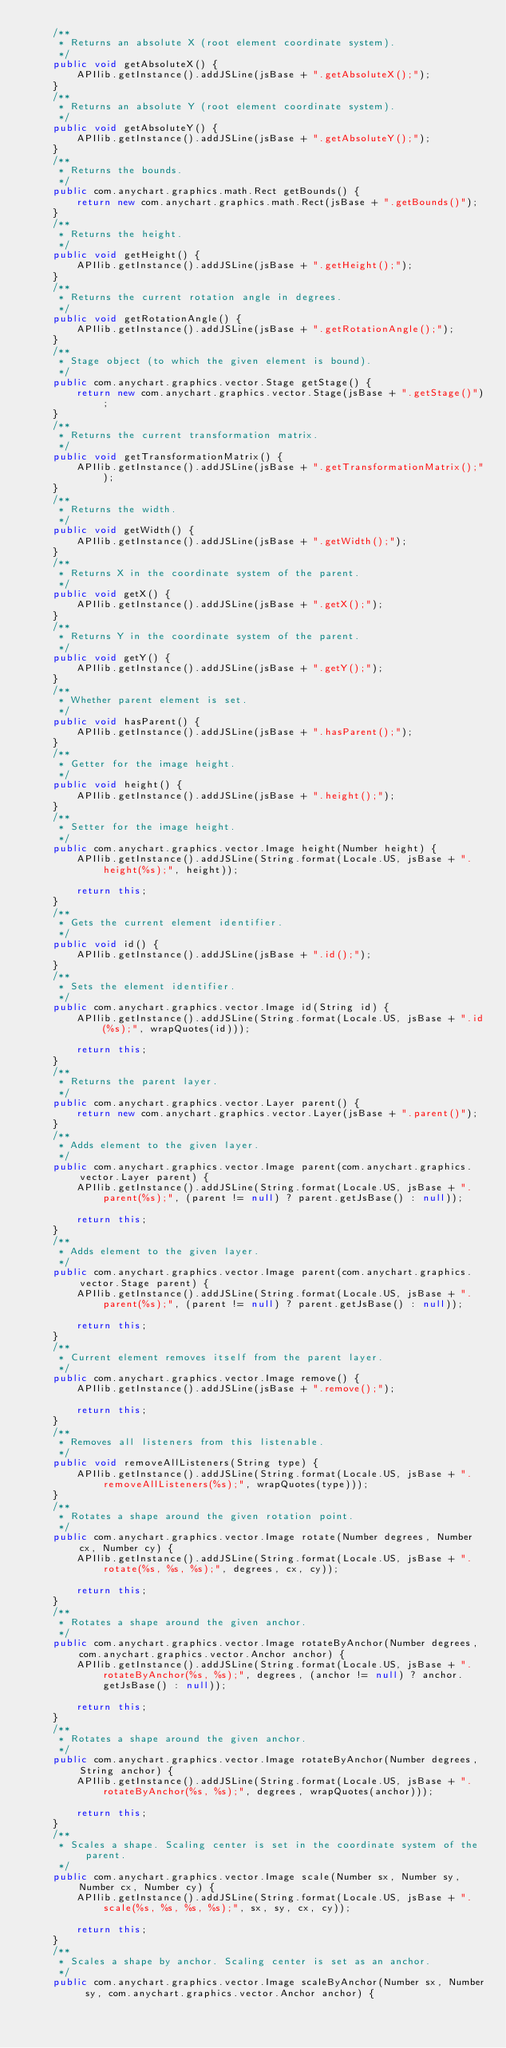<code> <loc_0><loc_0><loc_500><loc_500><_Java_>    /**
     * Returns an absolute X (root element coordinate system).
     */
    public void getAbsoluteX() {
        APIlib.getInstance().addJSLine(jsBase + ".getAbsoluteX();");
    }
    /**
     * Returns an absolute Y (root element coordinate system).
     */
    public void getAbsoluteY() {
        APIlib.getInstance().addJSLine(jsBase + ".getAbsoluteY();");
    }
    /**
     * Returns the bounds.
     */
    public com.anychart.graphics.math.Rect getBounds() {
        return new com.anychart.graphics.math.Rect(jsBase + ".getBounds()");
    }
    /**
     * Returns the height.
     */
    public void getHeight() {
        APIlib.getInstance().addJSLine(jsBase + ".getHeight();");
    }
    /**
     * Returns the current rotation angle in degrees.
     */
    public void getRotationAngle() {
        APIlib.getInstance().addJSLine(jsBase + ".getRotationAngle();");
    }
    /**
     * Stage object (to which the given element is bound).
     */
    public com.anychart.graphics.vector.Stage getStage() {
        return new com.anychart.graphics.vector.Stage(jsBase + ".getStage()");
    }
    /**
     * Returns the current transformation matrix.
     */
    public void getTransformationMatrix() {
        APIlib.getInstance().addJSLine(jsBase + ".getTransformationMatrix();");
    }
    /**
     * Returns the width.
     */
    public void getWidth() {
        APIlib.getInstance().addJSLine(jsBase + ".getWidth();");
    }
    /**
     * Returns X in the coordinate system of the parent.
     */
    public void getX() {
        APIlib.getInstance().addJSLine(jsBase + ".getX();");
    }
    /**
     * Returns Y in the coordinate system of the parent.
     */
    public void getY() {
        APIlib.getInstance().addJSLine(jsBase + ".getY();");
    }
    /**
     * Whether parent element is set.
     */
    public void hasParent() {
        APIlib.getInstance().addJSLine(jsBase + ".hasParent();");
    }
    /**
     * Getter for the image height.
     */
    public void height() {
        APIlib.getInstance().addJSLine(jsBase + ".height();");
    }
    /**
     * Setter for the image height.
     */
    public com.anychart.graphics.vector.Image height(Number height) {
        APIlib.getInstance().addJSLine(String.format(Locale.US, jsBase + ".height(%s);", height));

        return this;
    }
    /**
     * Gets the current element identifier.
     */
    public void id() {
        APIlib.getInstance().addJSLine(jsBase + ".id();");
    }
    /**
     * Sets the element identifier.
     */
    public com.anychart.graphics.vector.Image id(String id) {
        APIlib.getInstance().addJSLine(String.format(Locale.US, jsBase + ".id(%s);", wrapQuotes(id)));

        return this;
    }
    /**
     * Returns the parent layer.
     */
    public com.anychart.graphics.vector.Layer parent() {
        return new com.anychart.graphics.vector.Layer(jsBase + ".parent()");
    }
    /**
     * Adds element to the given layer.
     */
    public com.anychart.graphics.vector.Image parent(com.anychart.graphics.vector.Layer parent) {
        APIlib.getInstance().addJSLine(String.format(Locale.US, jsBase + ".parent(%s);", (parent != null) ? parent.getJsBase() : null));

        return this;
    }
    /**
     * Adds element to the given layer.
     */
    public com.anychart.graphics.vector.Image parent(com.anychart.graphics.vector.Stage parent) {
        APIlib.getInstance().addJSLine(String.format(Locale.US, jsBase + ".parent(%s);", (parent != null) ? parent.getJsBase() : null));

        return this;
    }
    /**
     * Current element removes itself from the parent layer.
     */
    public com.anychart.graphics.vector.Image remove() {
        APIlib.getInstance().addJSLine(jsBase + ".remove();");

        return this;
    }
    /**
     * Removes all listeners from this listenable.
     */
    public void removeAllListeners(String type) {
        APIlib.getInstance().addJSLine(String.format(Locale.US, jsBase + ".removeAllListeners(%s);", wrapQuotes(type)));
    }
    /**
     * Rotates a shape around the given rotation point.
     */
    public com.anychart.graphics.vector.Image rotate(Number degrees, Number cx, Number cy) {
        APIlib.getInstance().addJSLine(String.format(Locale.US, jsBase + ".rotate(%s, %s, %s);", degrees, cx, cy));

        return this;
    }
    /**
     * Rotates a shape around the given anchor.
     */
    public com.anychart.graphics.vector.Image rotateByAnchor(Number degrees, com.anychart.graphics.vector.Anchor anchor) {
        APIlib.getInstance().addJSLine(String.format(Locale.US, jsBase + ".rotateByAnchor(%s, %s);", degrees, (anchor != null) ? anchor.getJsBase() : null));

        return this;
    }
    /**
     * Rotates a shape around the given anchor.
     */
    public com.anychart.graphics.vector.Image rotateByAnchor(Number degrees, String anchor) {
        APIlib.getInstance().addJSLine(String.format(Locale.US, jsBase + ".rotateByAnchor(%s, %s);", degrees, wrapQuotes(anchor)));

        return this;
    }
    /**
     * Scales a shape. Scaling center is set in the coordinate system of the parent.
     */
    public com.anychart.graphics.vector.Image scale(Number sx, Number sy, Number cx, Number cy) {
        APIlib.getInstance().addJSLine(String.format(Locale.US, jsBase + ".scale(%s, %s, %s, %s);", sx, sy, cx, cy));

        return this;
    }
    /**
     * Scales a shape by anchor. Scaling center is set as an anchor.
     */
    public com.anychart.graphics.vector.Image scaleByAnchor(Number sx, Number sy, com.anychart.graphics.vector.Anchor anchor) {</code> 